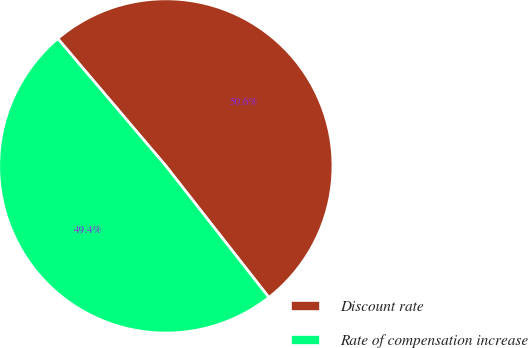<chart> <loc_0><loc_0><loc_500><loc_500><pie_chart><fcel>Discount rate<fcel>Rate of compensation increase<nl><fcel>50.62%<fcel>49.38%<nl></chart> 